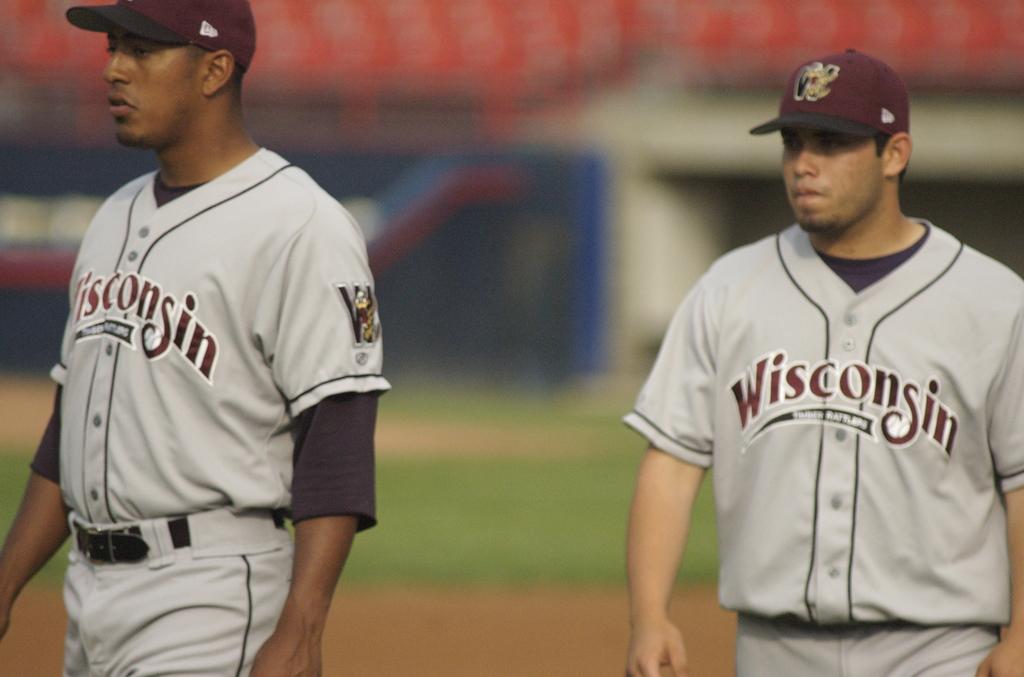What is the name of the team on the players jersey?
Keep it short and to the point. Wisconsin. What state does this team play for?
Your response must be concise. Wisconsin. 